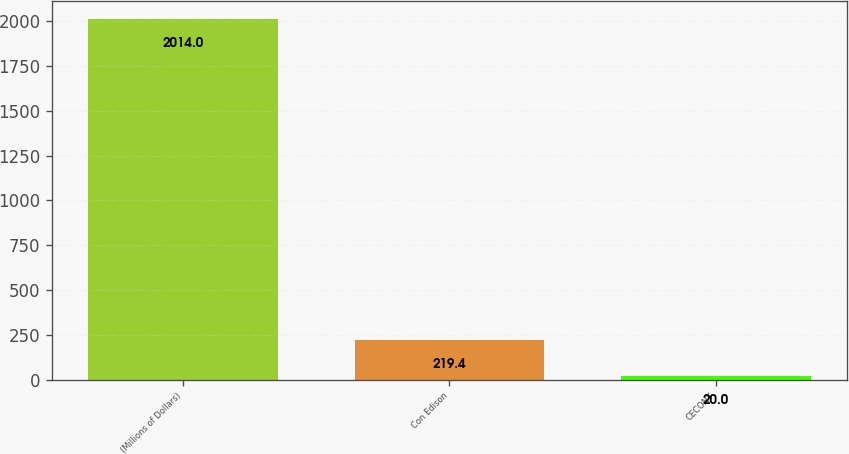Convert chart to OTSL. <chart><loc_0><loc_0><loc_500><loc_500><bar_chart><fcel>(Millions of Dollars)<fcel>Con Edison<fcel>CECONY<nl><fcel>2014<fcel>219.4<fcel>20<nl></chart> 